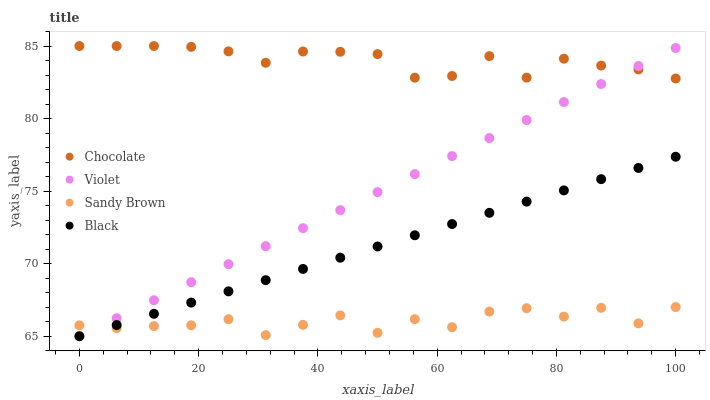Does Sandy Brown have the minimum area under the curve?
Answer yes or no. Yes. Does Chocolate have the maximum area under the curve?
Answer yes or no. Yes. Does Violet have the minimum area under the curve?
Answer yes or no. No. Does Violet have the maximum area under the curve?
Answer yes or no. No. Is Black the smoothest?
Answer yes or no. Yes. Is Sandy Brown the roughest?
Answer yes or no. Yes. Is Violet the smoothest?
Answer yes or no. No. Is Violet the roughest?
Answer yes or no. No. Does Black have the lowest value?
Answer yes or no. Yes. Does Sandy Brown have the lowest value?
Answer yes or no. No. Does Chocolate have the highest value?
Answer yes or no. Yes. Does Violet have the highest value?
Answer yes or no. No. Is Sandy Brown less than Chocolate?
Answer yes or no. Yes. Is Chocolate greater than Black?
Answer yes or no. Yes. Does Chocolate intersect Violet?
Answer yes or no. Yes. Is Chocolate less than Violet?
Answer yes or no. No. Is Chocolate greater than Violet?
Answer yes or no. No. Does Sandy Brown intersect Chocolate?
Answer yes or no. No. 